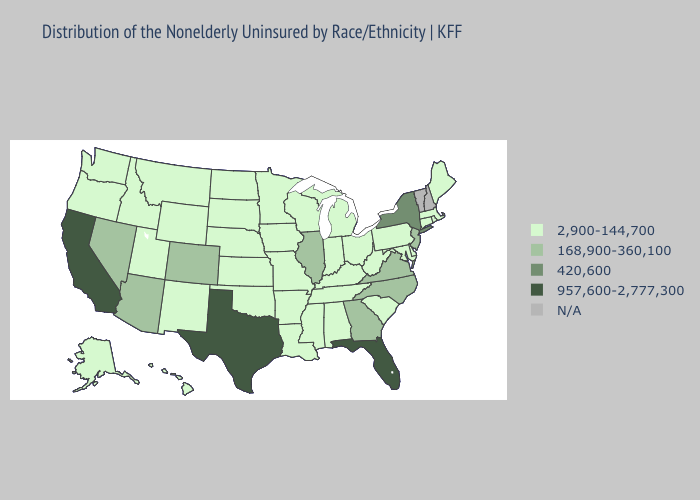Name the states that have a value in the range 957,600-2,777,300?
Concise answer only. California, Florida, Texas. Which states have the highest value in the USA?
Give a very brief answer. California, Florida, Texas. Does Tennessee have the lowest value in the USA?
Quick response, please. Yes. Name the states that have a value in the range N/A?
Concise answer only. New Hampshire, Vermont. Does the first symbol in the legend represent the smallest category?
Keep it brief. Yes. What is the highest value in the MidWest ?
Be succinct. 168,900-360,100. Name the states that have a value in the range N/A?
Write a very short answer. New Hampshire, Vermont. What is the lowest value in states that border Kansas?
Concise answer only. 2,900-144,700. Name the states that have a value in the range N/A?
Be succinct. New Hampshire, Vermont. Name the states that have a value in the range 168,900-360,100?
Give a very brief answer. Arizona, Colorado, Georgia, Illinois, Nevada, New Jersey, North Carolina, Virginia. Among the states that border Idaho , which have the highest value?
Give a very brief answer. Nevada. What is the value of Nebraska?
Short answer required. 2,900-144,700. Name the states that have a value in the range N/A?
Keep it brief. New Hampshire, Vermont. 